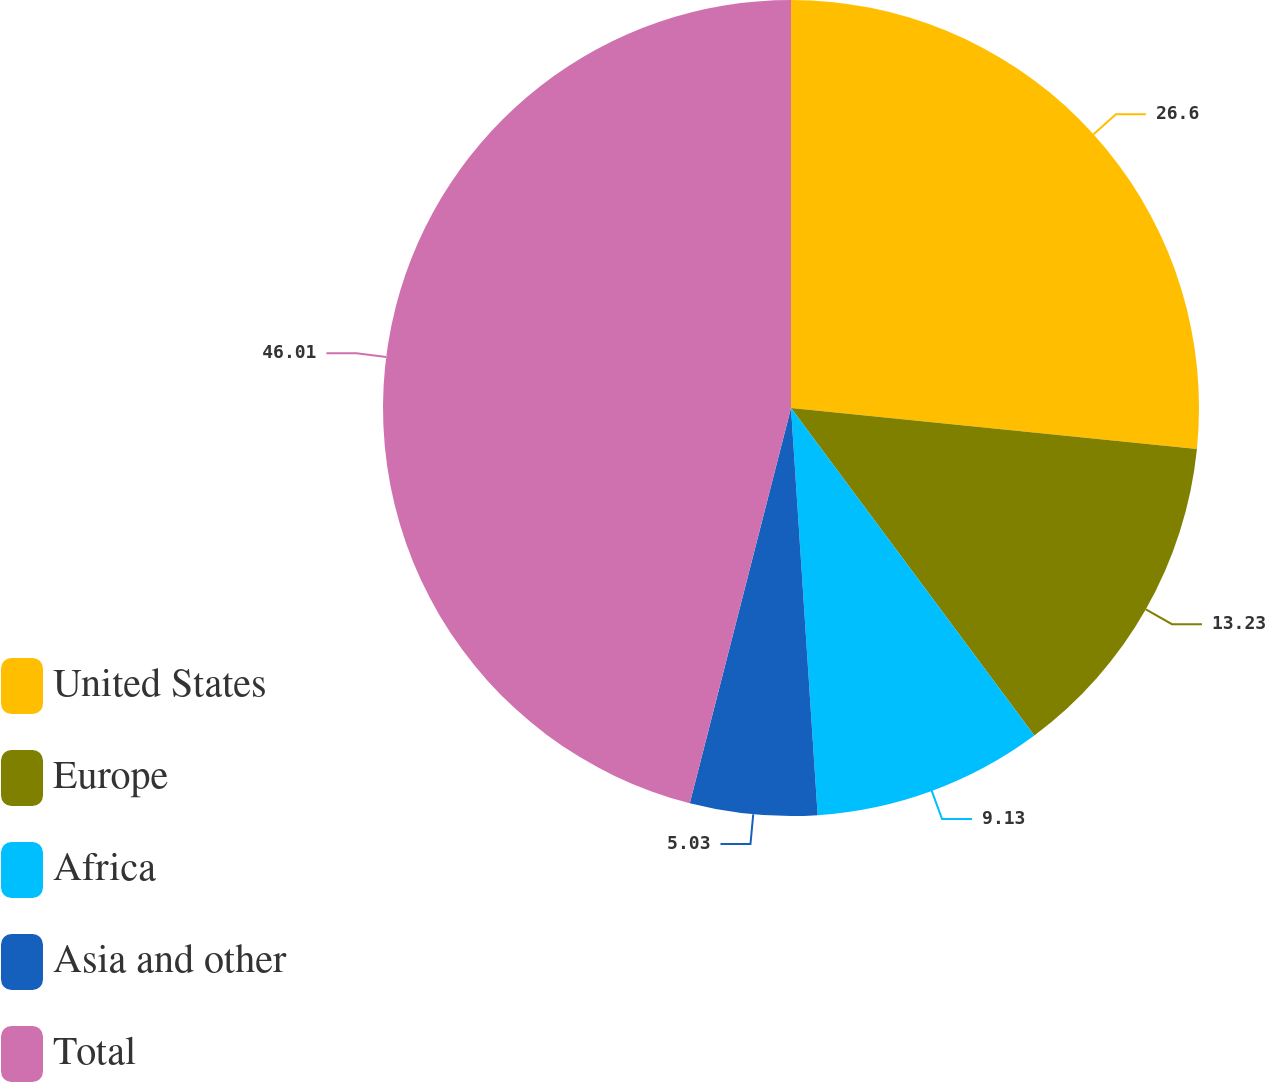<chart> <loc_0><loc_0><loc_500><loc_500><pie_chart><fcel>United States<fcel>Europe<fcel>Africa<fcel>Asia and other<fcel>Total<nl><fcel>26.6%<fcel>13.23%<fcel>9.13%<fcel>5.03%<fcel>46.01%<nl></chart> 